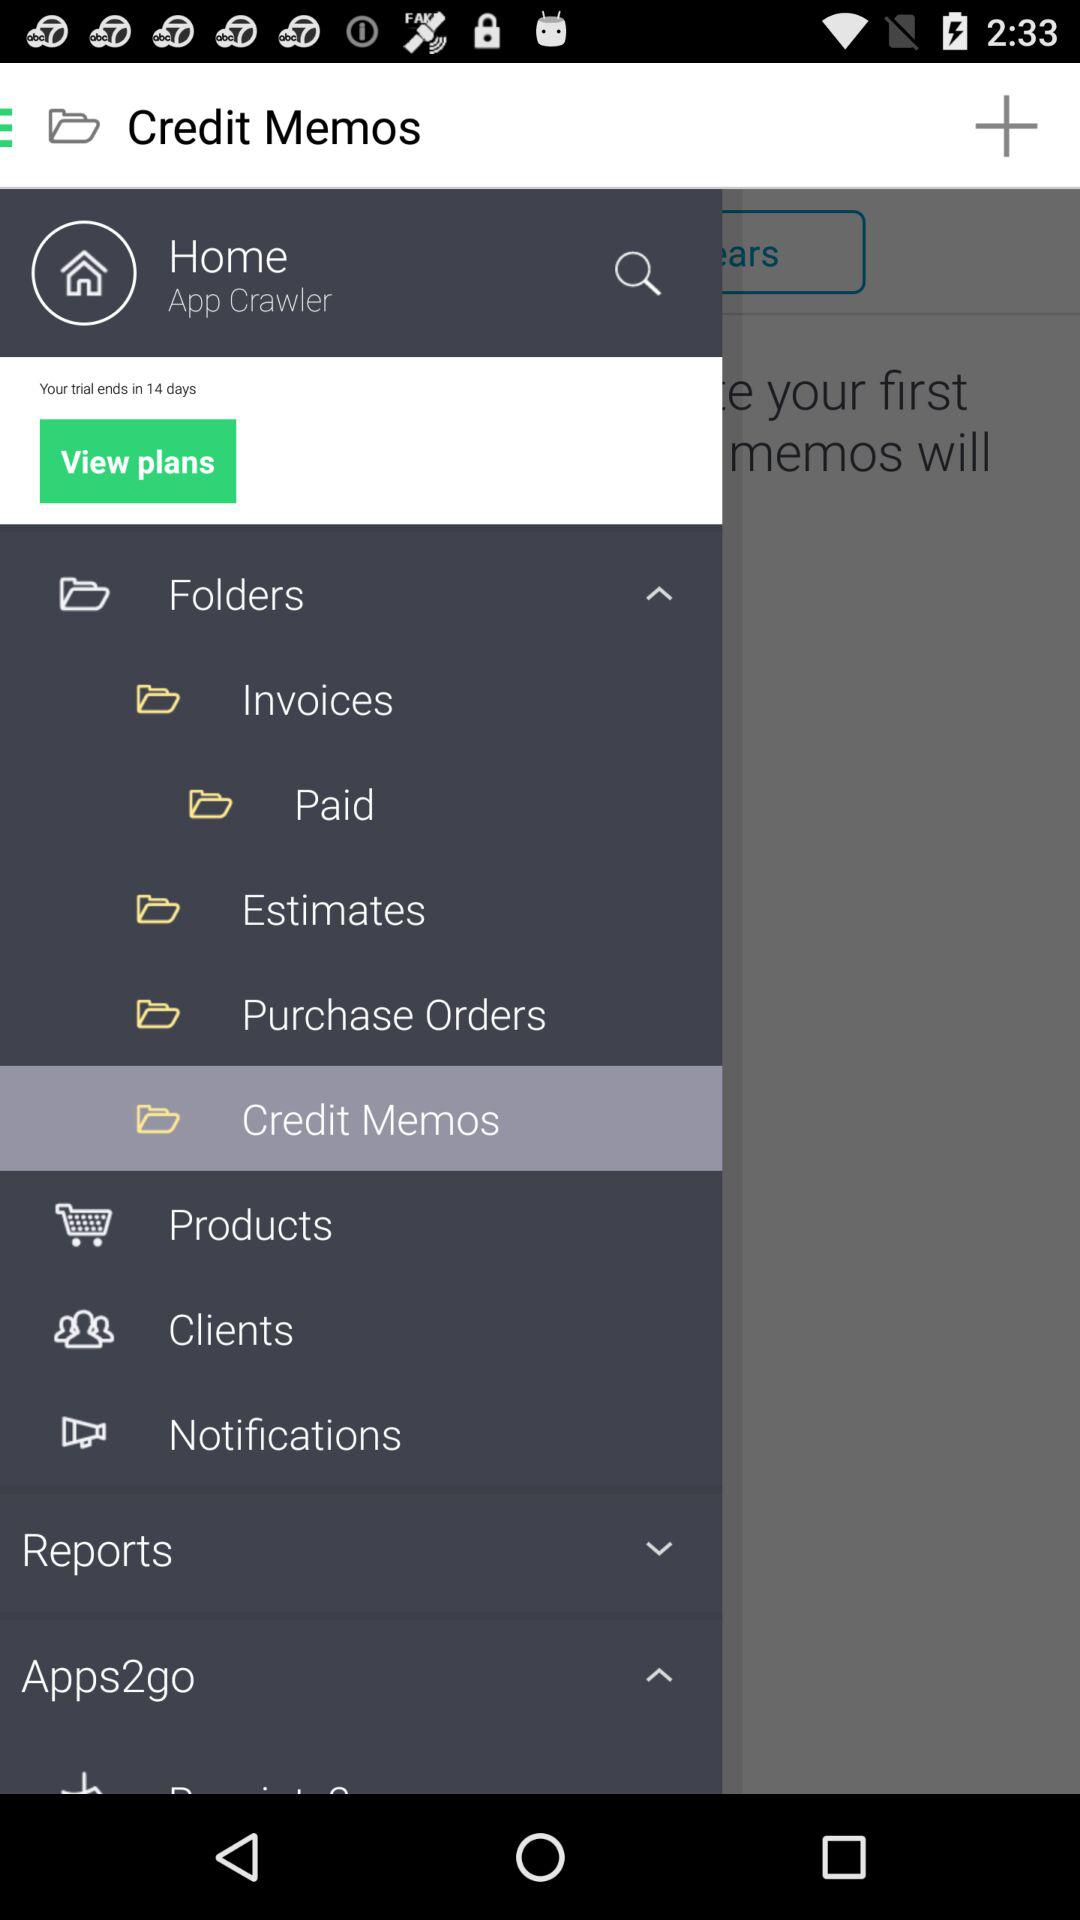In how many days will the trial end? The trial will end in 14 days. 